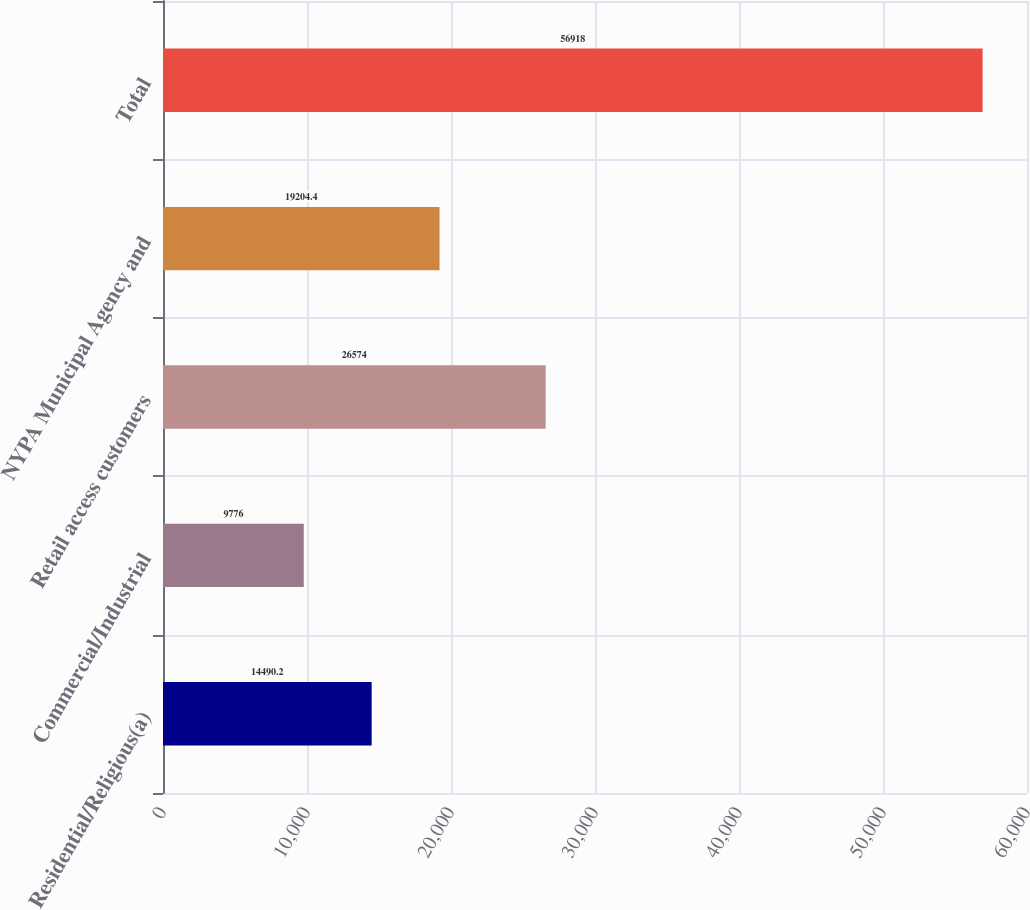Convert chart. <chart><loc_0><loc_0><loc_500><loc_500><bar_chart><fcel>Residential/Religious(a)<fcel>Commercial/Industrial<fcel>Retail access customers<fcel>NYPA Municipal Agency and<fcel>Total<nl><fcel>14490.2<fcel>9776<fcel>26574<fcel>19204.4<fcel>56918<nl></chart> 